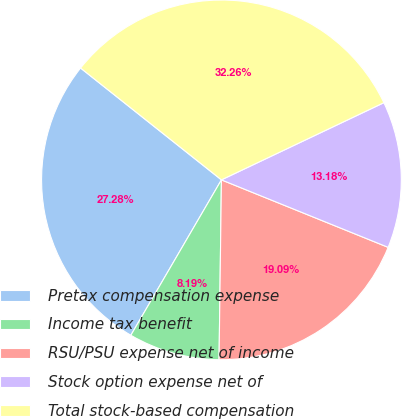Convert chart to OTSL. <chart><loc_0><loc_0><loc_500><loc_500><pie_chart><fcel>Pretax compensation expense<fcel>Income tax benefit<fcel>RSU/PSU expense net of income<fcel>Stock option expense net of<fcel>Total stock-based compensation<nl><fcel>27.28%<fcel>8.19%<fcel>19.09%<fcel>13.18%<fcel>32.26%<nl></chart> 